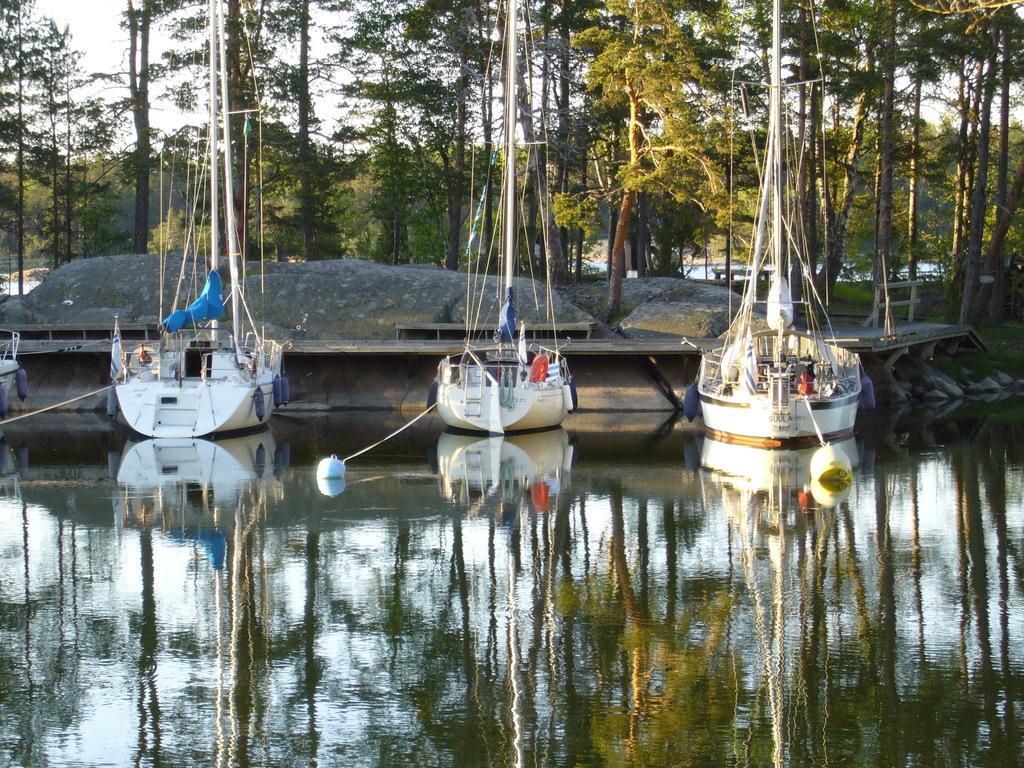Could you give a brief overview of what you see in this image? In this image we can see some boats on the water, there are some rocks, trees, and a bench, in the background we can see the sky. 